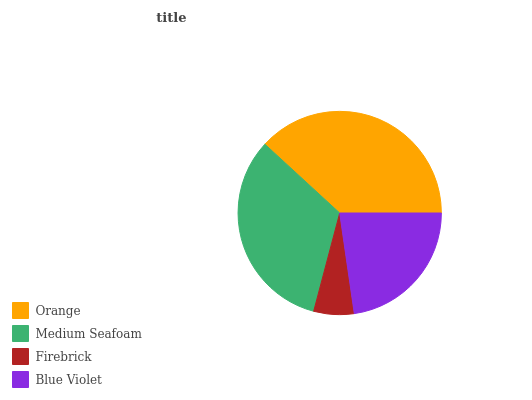Is Firebrick the minimum?
Answer yes or no. Yes. Is Orange the maximum?
Answer yes or no. Yes. Is Medium Seafoam the minimum?
Answer yes or no. No. Is Medium Seafoam the maximum?
Answer yes or no. No. Is Orange greater than Medium Seafoam?
Answer yes or no. Yes. Is Medium Seafoam less than Orange?
Answer yes or no. Yes. Is Medium Seafoam greater than Orange?
Answer yes or no. No. Is Orange less than Medium Seafoam?
Answer yes or no. No. Is Medium Seafoam the high median?
Answer yes or no. Yes. Is Blue Violet the low median?
Answer yes or no. Yes. Is Firebrick the high median?
Answer yes or no. No. Is Firebrick the low median?
Answer yes or no. No. 